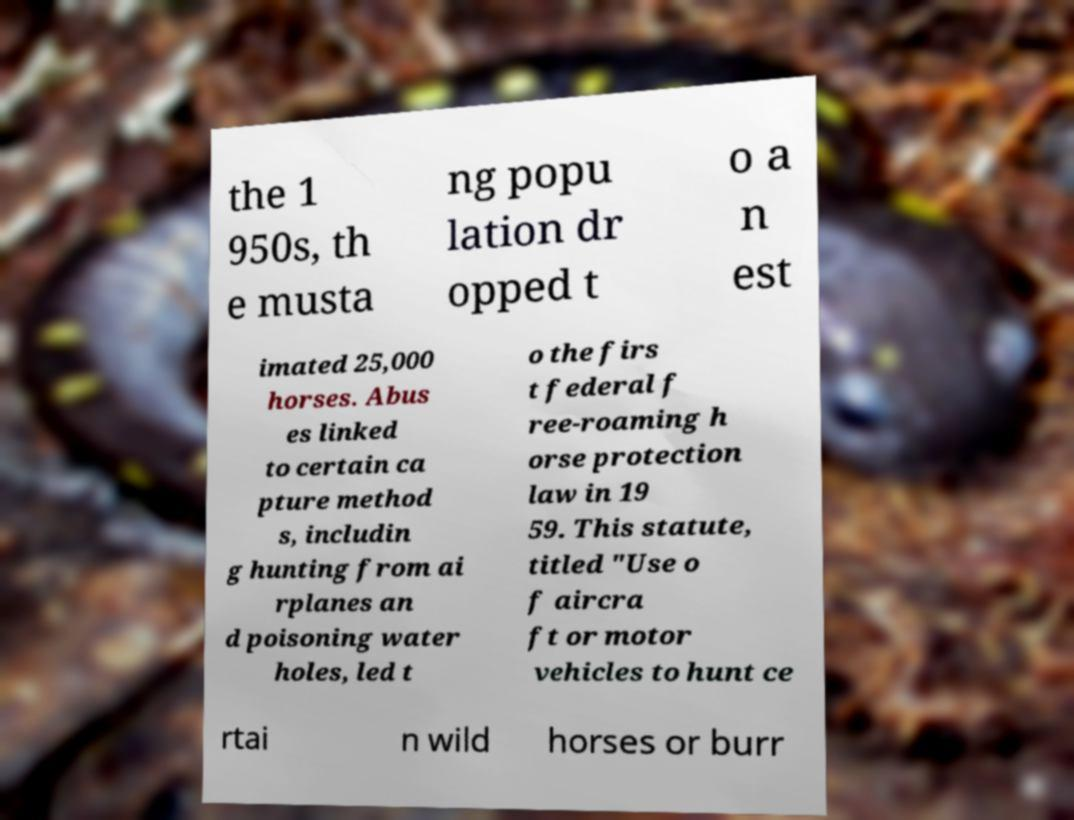Can you accurately transcribe the text from the provided image for me? the 1 950s, th e musta ng popu lation dr opped t o a n est imated 25,000 horses. Abus es linked to certain ca pture method s, includin g hunting from ai rplanes an d poisoning water holes, led t o the firs t federal f ree-roaming h orse protection law in 19 59. This statute, titled "Use o f aircra ft or motor vehicles to hunt ce rtai n wild horses or burr 